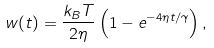Convert formula to latex. <formula><loc_0><loc_0><loc_500><loc_500>w ( t ) = \frac { k _ { B } T } { 2 \eta } \left ( 1 - e ^ { - 4 \eta t / \gamma } \right ) ,</formula> 